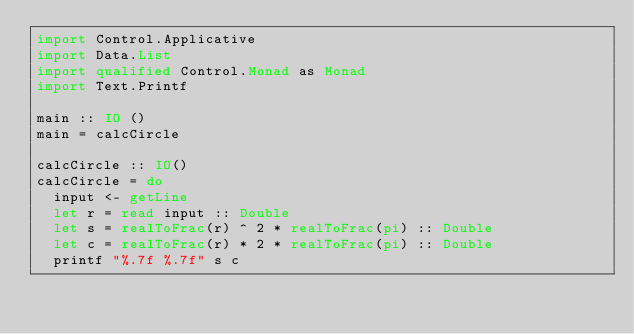Convert code to text. <code><loc_0><loc_0><loc_500><loc_500><_Haskell_>import Control.Applicative
import Data.List
import qualified Control.Monad as Monad
import Text.Printf

main :: IO ()
main = calcCircle  

calcCircle :: IO()
calcCircle = do 
  input <- getLine  
  let r = read input :: Double
  let s = realToFrac(r) ^ 2 * realToFrac(pi) :: Double 
  let c = realToFrac(r) * 2 * realToFrac(pi) :: Double 
  printf "%.7f %.7f" s c
</code> 